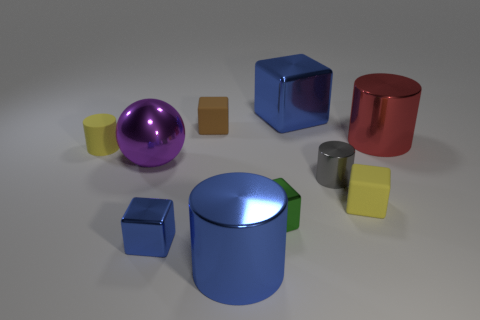Subtract all green blocks. How many blocks are left? 4 Subtract all brown cubes. How many cubes are left? 4 Subtract all gray blocks. Subtract all blue cylinders. How many blocks are left? 5 Subtract all spheres. How many objects are left? 9 Add 7 large blue shiny cylinders. How many large blue shiny cylinders exist? 8 Subtract 0 green cylinders. How many objects are left? 10 Subtract all tiny blue shiny cubes. Subtract all blue metal cylinders. How many objects are left? 8 Add 7 blue blocks. How many blue blocks are left? 9 